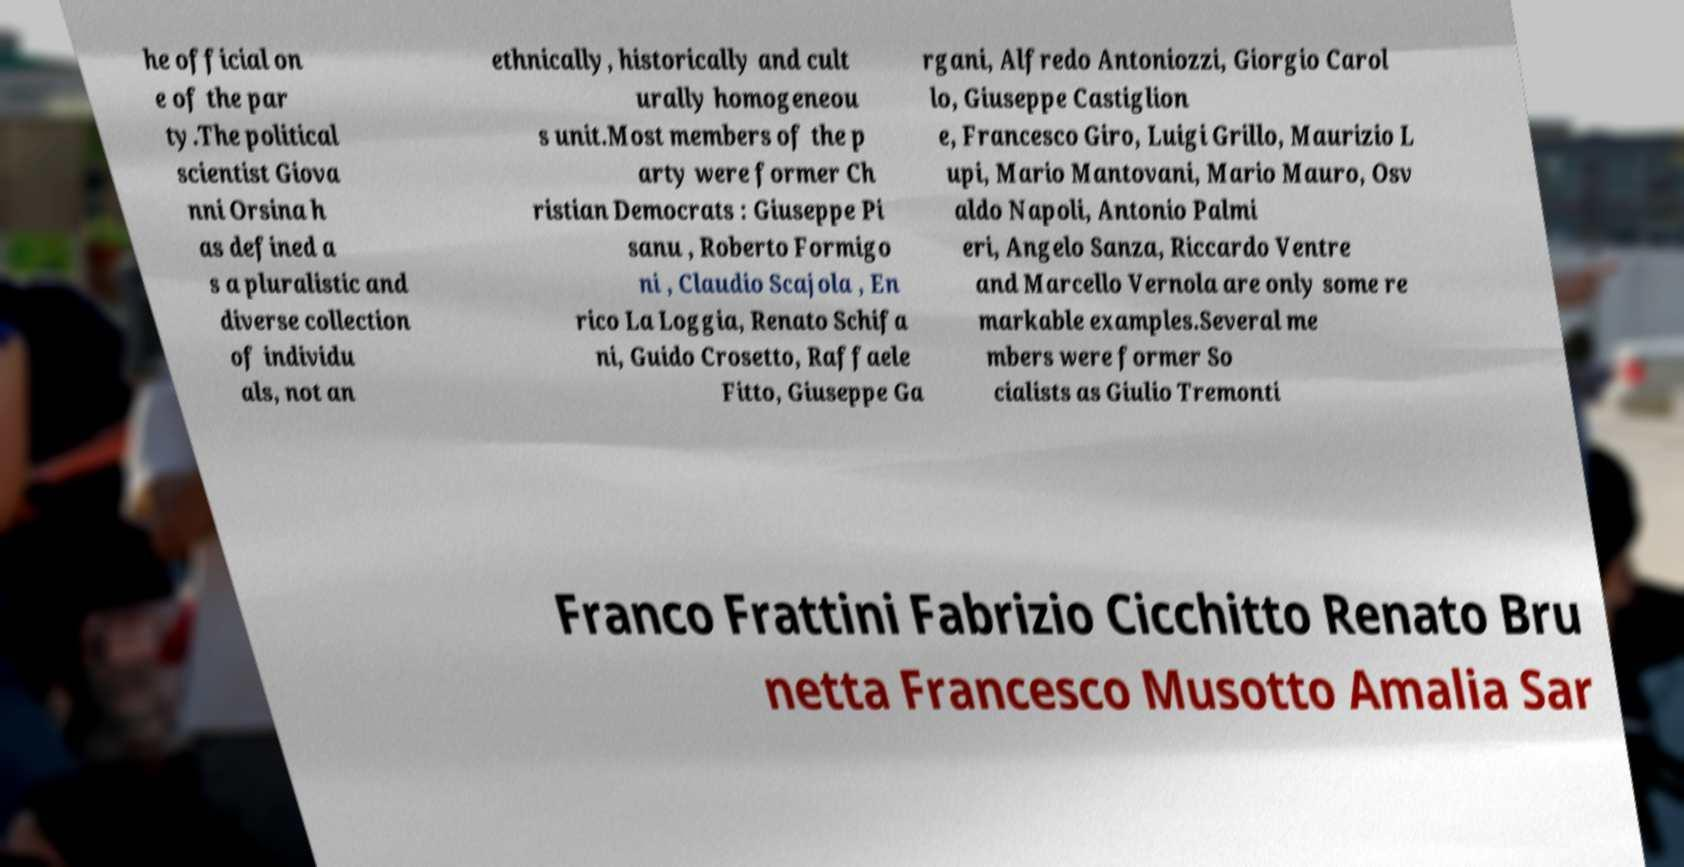Please read and relay the text visible in this image. What does it say? he official on e of the par ty.The political scientist Giova nni Orsina h as defined a s a pluralistic and diverse collection of individu als, not an ethnically, historically and cult urally homogeneou s unit.Most members of the p arty were former Ch ristian Democrats : Giuseppe Pi sanu , Roberto Formigo ni , Claudio Scajola , En rico La Loggia, Renato Schifa ni, Guido Crosetto, Raffaele Fitto, Giuseppe Ga rgani, Alfredo Antoniozzi, Giorgio Carol lo, Giuseppe Castiglion e, Francesco Giro, Luigi Grillo, Maurizio L upi, Mario Mantovani, Mario Mauro, Osv aldo Napoli, Antonio Palmi eri, Angelo Sanza, Riccardo Ventre and Marcello Vernola are only some re markable examples.Several me mbers were former So cialists as Giulio Tremonti Franco Frattini Fabrizio Cicchitto Renato Bru netta Francesco Musotto Amalia Sar 